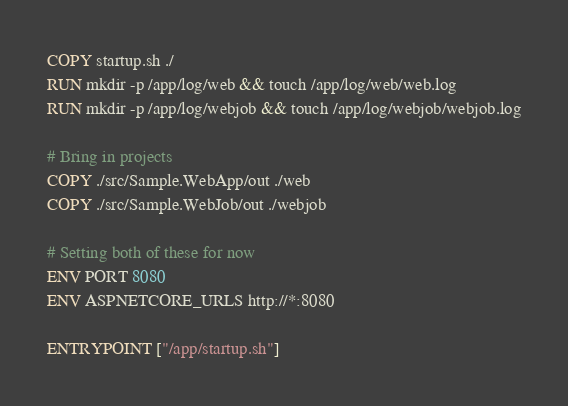Convert code to text. <code><loc_0><loc_0><loc_500><loc_500><_Dockerfile_>COPY startup.sh ./
RUN mkdir -p /app/log/web && touch /app/log/web/web.log
RUN mkdir -p /app/log/webjob && touch /app/log/webjob/webjob.log

# Bring in projects
COPY ./src/Sample.WebApp/out ./web
COPY ./src/Sample.WebJob/out ./webjob

# Setting both of these for now
ENV PORT 8080
ENV ASPNETCORE_URLS http://*:8080

ENTRYPOINT ["/app/startup.sh"]</code> 